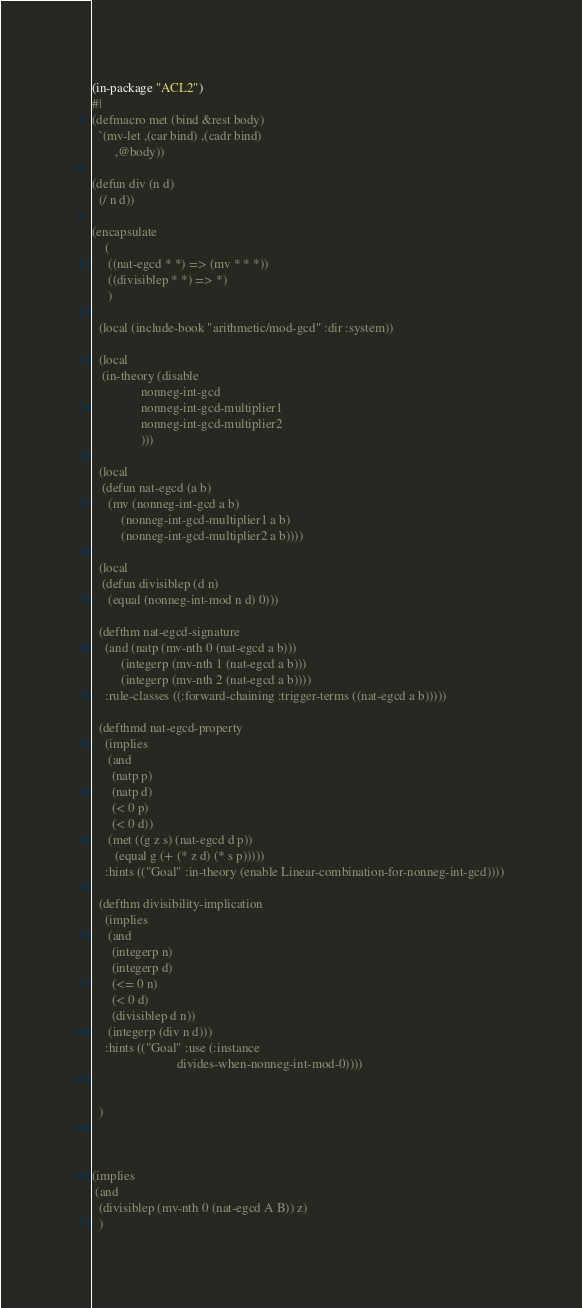Convert code to text. <code><loc_0><loc_0><loc_500><loc_500><_Lisp_>(in-package "ACL2")
#|
(defmacro met (bind &rest body)
  `(mv-let ,(car bind) ,(cadr bind)
	   ,@body))

(defun div (n d)
  (/ n d))

(encapsulate
    (
     ((nat-egcd * *) => (mv * * *))
     ((divisiblep * *) => *)
     )

  (local (include-book "arithmetic/mod-gcd" :dir :system))

  (local
   (in-theory (disable
               nonneg-int-gcd
               nonneg-int-gcd-multiplier1
               nonneg-int-gcd-multiplier2
               )))

  (local 
   (defun nat-egcd (a b)
     (mv (nonneg-int-gcd a b)
         (nonneg-int-gcd-multiplier1 a b)
         (nonneg-int-gcd-multiplier2 a b))))

  (local 
   (defun divisiblep (d n)
     (equal (nonneg-int-mod n d) 0)))

  (defthm nat-egcd-signature
    (and (natp (mv-nth 0 (nat-egcd a b)))
         (integerp (mv-nth 1 (nat-egcd a b)))
         (integerp (mv-nth 2 (nat-egcd a b))))
    :rule-classes ((:forward-chaining :trigger-terms ((nat-egcd a b)))))

  (defthmd nat-egcd-property
    (implies
     (and
      (natp p)
      (natp d)
      (< 0 p)
      (< 0 d))
     (met ((g z s) (nat-egcd d p))
       (equal g (+ (* z d) (* s p)))))
    :hints (("Goal" :in-theory (enable Linear-combination-for-nonneg-int-gcd))))

  (defthm divisibility-implication
    (implies
     (and
      (integerp n)
      (integerp d)
      (<= 0 n)
      (< 0 d)
      (divisiblep d n))
     (integerp (div n d)))
    :hints (("Goal" :use (:instance
                          divides-when-nonneg-int-mod-0))))
                          

  )



(implies
 (and
  (divisiblep (mv-nth 0 (nat-egcd A B)) z)
  )</code> 